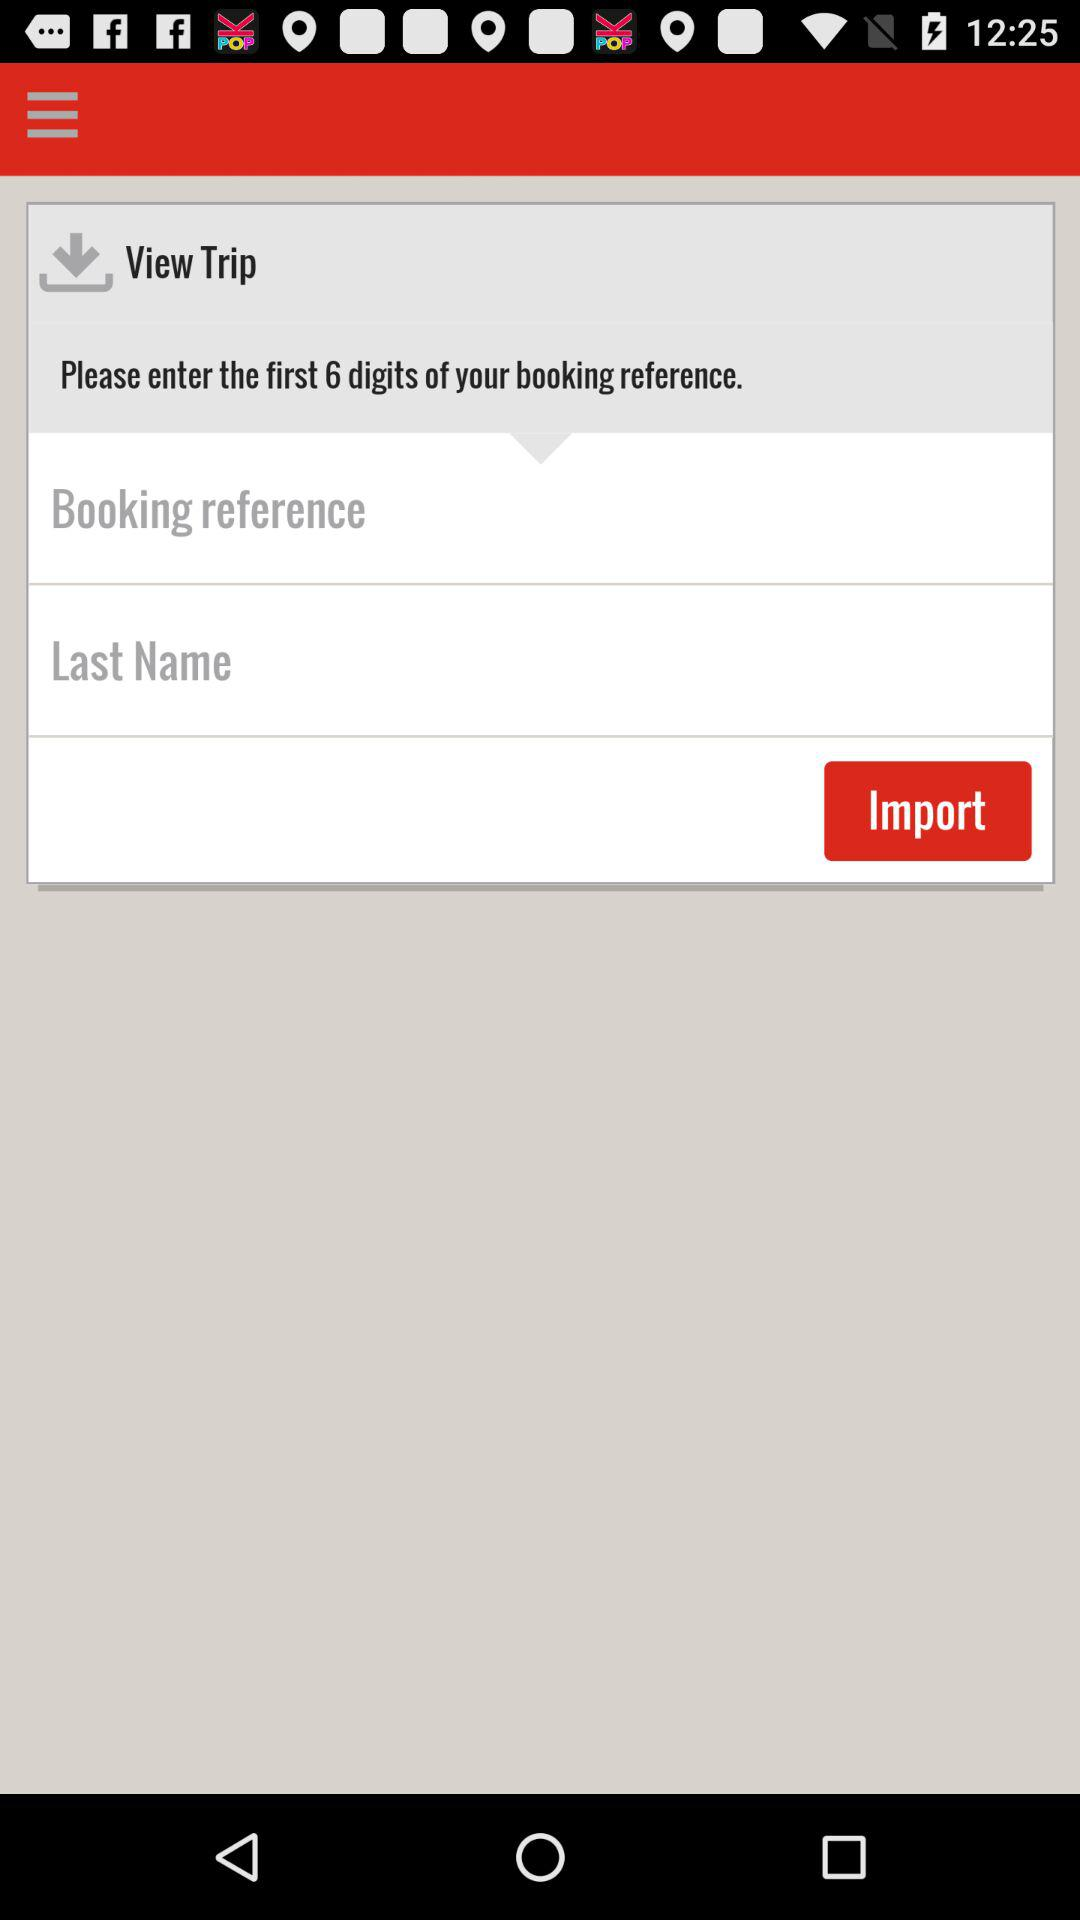How many digits are in the booking reference?
Answer the question using a single word or phrase. 6 